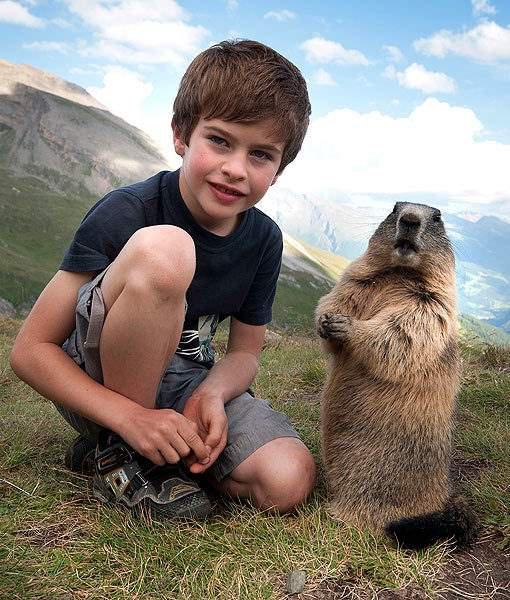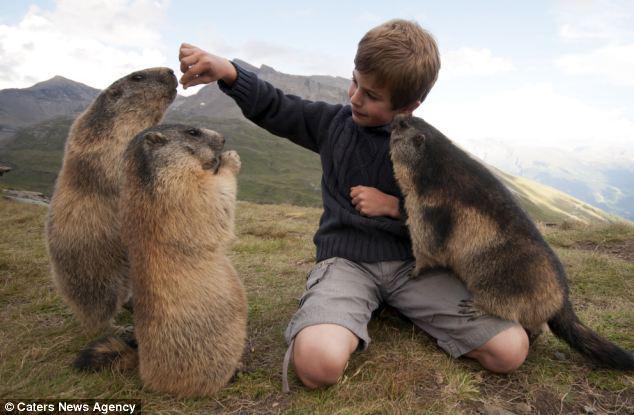The first image is the image on the left, the second image is the image on the right. Analyze the images presented: Is the assertion "There are six marmots." valid? Answer yes or no. No. The first image is the image on the left, the second image is the image on the right. Assess this claim about the two images: "In the right image, there are at least three animals interacting with a young boy.". Correct or not? Answer yes or no. Yes. 